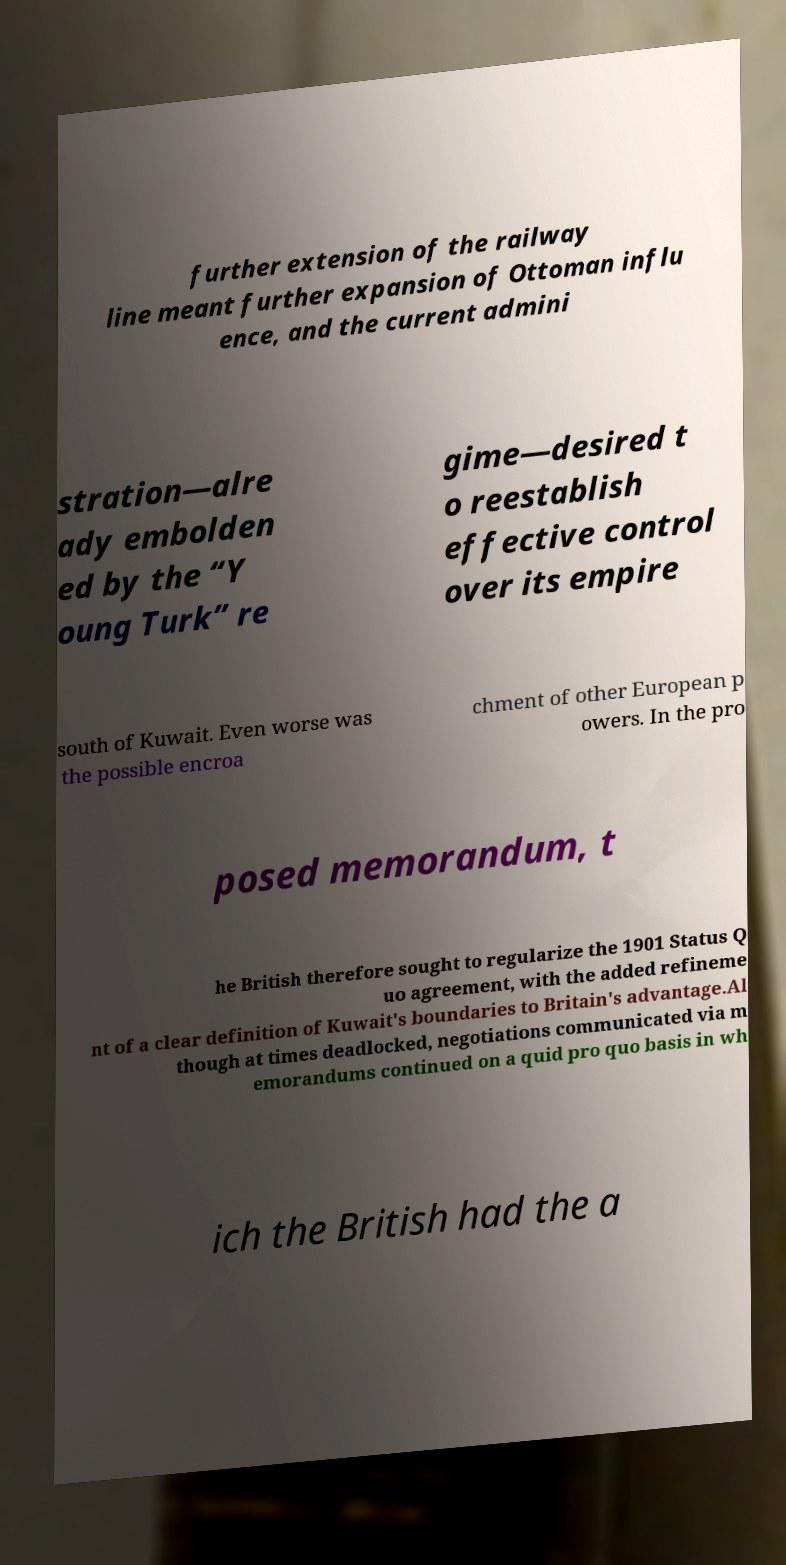For documentation purposes, I need the text within this image transcribed. Could you provide that? further extension of the railway line meant further expansion of Ottoman influ ence, and the current admini stration—alre ady embolden ed by the “Y oung Turk” re gime—desired t o reestablish effective control over its empire south of Kuwait. Even worse was the possible encroa chment of other European p owers. In the pro posed memorandum, t he British therefore sought to regularize the 1901 Status Q uo agreement, with the added refineme nt of a clear definition of Kuwait's boundaries to Britain's advantage.Al though at times deadlocked, negotiations communicated via m emorandums continued on a quid pro quo basis in wh ich the British had the a 